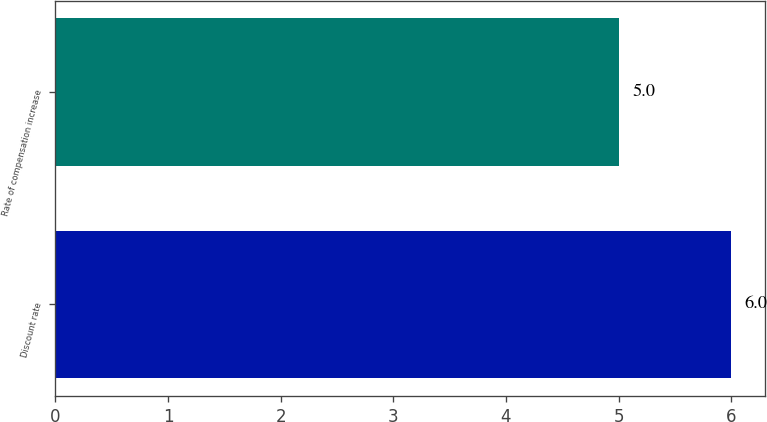Convert chart to OTSL. <chart><loc_0><loc_0><loc_500><loc_500><bar_chart><fcel>Discount rate<fcel>Rate of compensation increase<nl><fcel>6<fcel>5<nl></chart> 